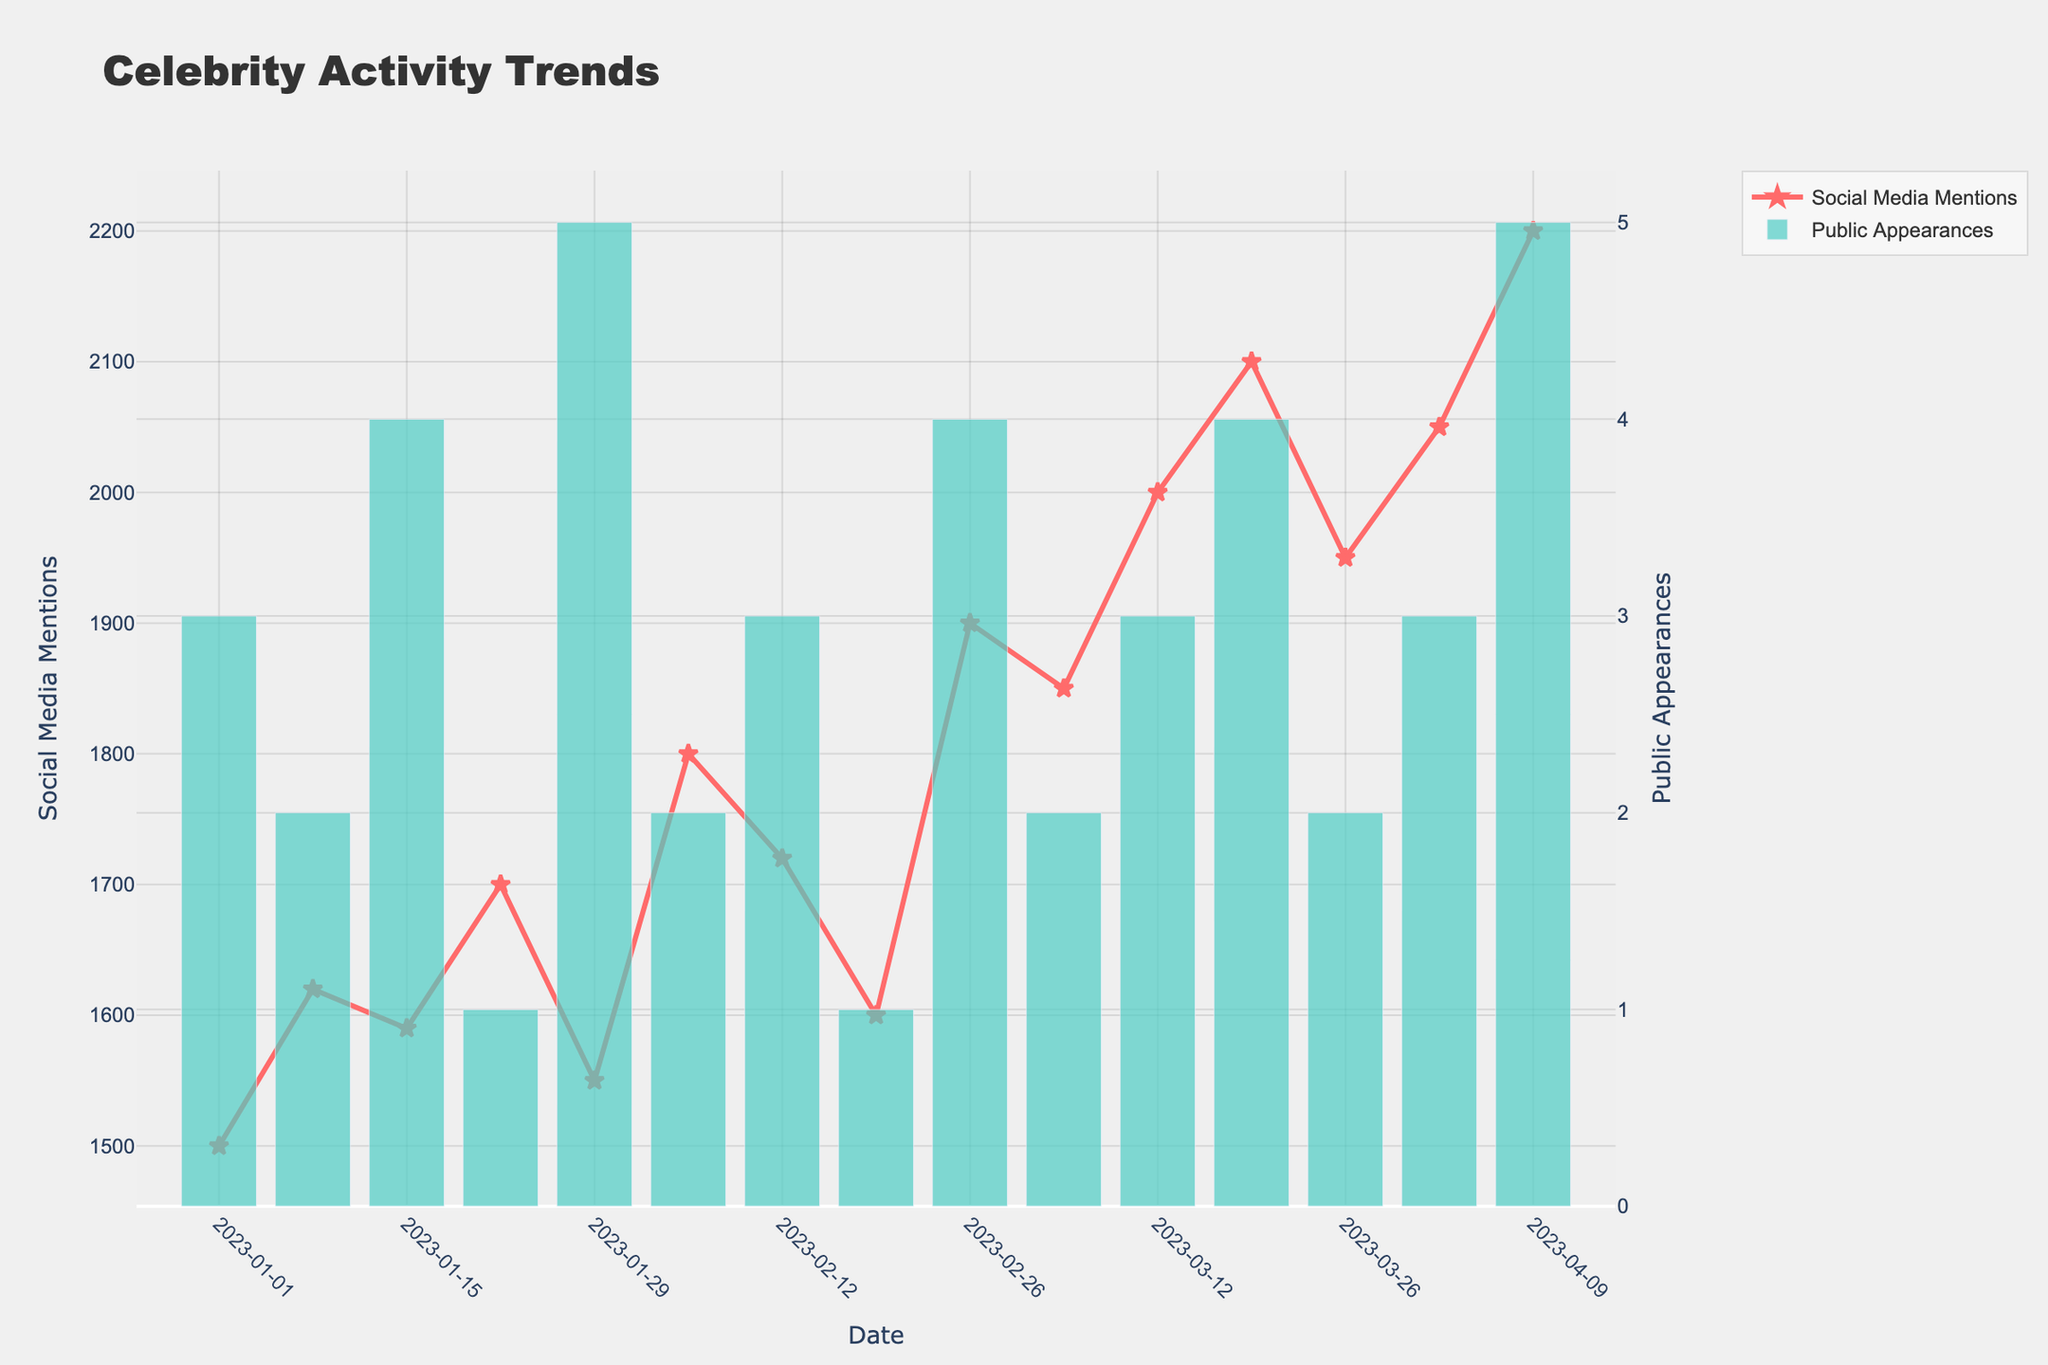What's the title of the figure? The title of the figure is displayed at the top and it captures the main subject of the plot. In this case, it reads "Celebrity Activity Trends".
Answer: Celebrity Activity Trends How many social media mentions were there on March 12, 2023? Look at the date axis to find March 12, 2023, then refer to the "Social Media Mentions" line. The data point for that date is around 2000.
Answer: 2000 Which had more entries, social media mentions or public appearances? Check the number of data points and bars shown on the figure for both social media mentions and public appearances. Both have entries for every date on the x-axis.
Answer: Equal What is the general trend of social media mentions over time? Look at the "Social Media Mentions" line. It generally trends upwards from around 1500 to 2200 over the given time period.
Answer: Upward When did the highest number of public appearances occur? Look for the highest bar in the "Public Appearances" part of the plot. The tallest bar is in the week of April 9, 2023.
Answer: April 9, 2023 How would you describe the relationship between social media mentions and public appearances? Visually inspect both the line for social media mentions and the bars for public appearances. The trends do not show a direct correlation; sometimes when public appearances are high, social media mentions are low, and vice versa.
Answer: Weak or no direct correlation What is the range of public appearances over the observed period? Identify the lowest and highest points of the "Public Appearances" bars. The minimum appears to be 1 and the maximum is 5.
Answer: 1 to 5 How many times did public appearances reach their maximum value? Count the number of bars that reach the highest value (5 appearances). These occur twice, on January 29, 2023, and April 9, 2023.
Answer: Twice If you were to identify a month with consistently high social media mentions, which month would it be? Check the line for social media mentions and observe which month has consistently high values. March 2023 had mentions around or above 2000 for most of the month.
Answer: March 2023 Was there ever a week where social media mentions decreased while public appearances increased? Compare the "Social Media Mentions" line and "Public Appearances" bars week by week. On January 29, 2023, social media mentions decreased from the previous week, while public appearances increased from 1 to 5.
Answer: January 29, 2023 